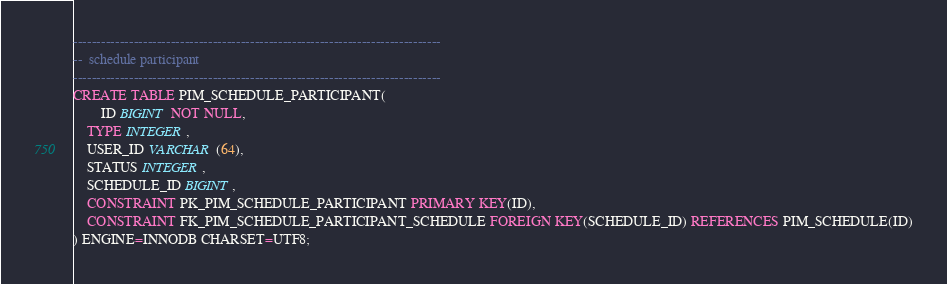<code> <loc_0><loc_0><loc_500><loc_500><_SQL_>

-------------------------------------------------------------------------------
--  schedule participant
-------------------------------------------------------------------------------
CREATE TABLE PIM_SCHEDULE_PARTICIPANT(
        ID BIGINT NOT NULL,
	TYPE INTEGER,
	USER_ID VARCHAR(64),
	STATUS INTEGER,
	SCHEDULE_ID BIGINT,
	CONSTRAINT PK_PIM_SCHEDULE_PARTICIPANT PRIMARY KEY(ID),
	CONSTRAINT FK_PIM_SCHEDULE_PARTICIPANT_SCHEDULE FOREIGN KEY(SCHEDULE_ID) REFERENCES PIM_SCHEDULE(ID)
) ENGINE=INNODB CHARSET=UTF8;

</code> 